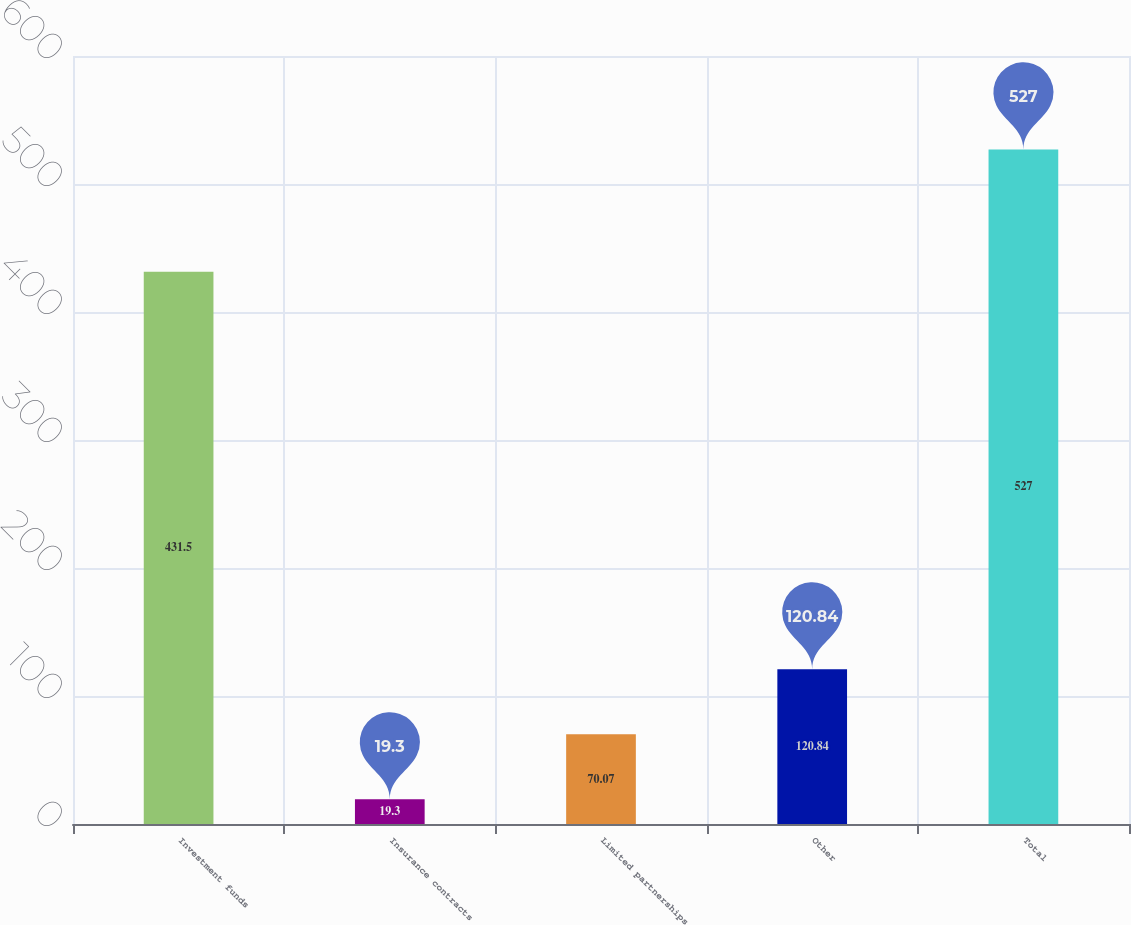Convert chart. <chart><loc_0><loc_0><loc_500><loc_500><bar_chart><fcel>Investment funds<fcel>Insurance contracts<fcel>Limited partnerships<fcel>Other<fcel>Total<nl><fcel>431.5<fcel>19.3<fcel>70.07<fcel>120.84<fcel>527<nl></chart> 